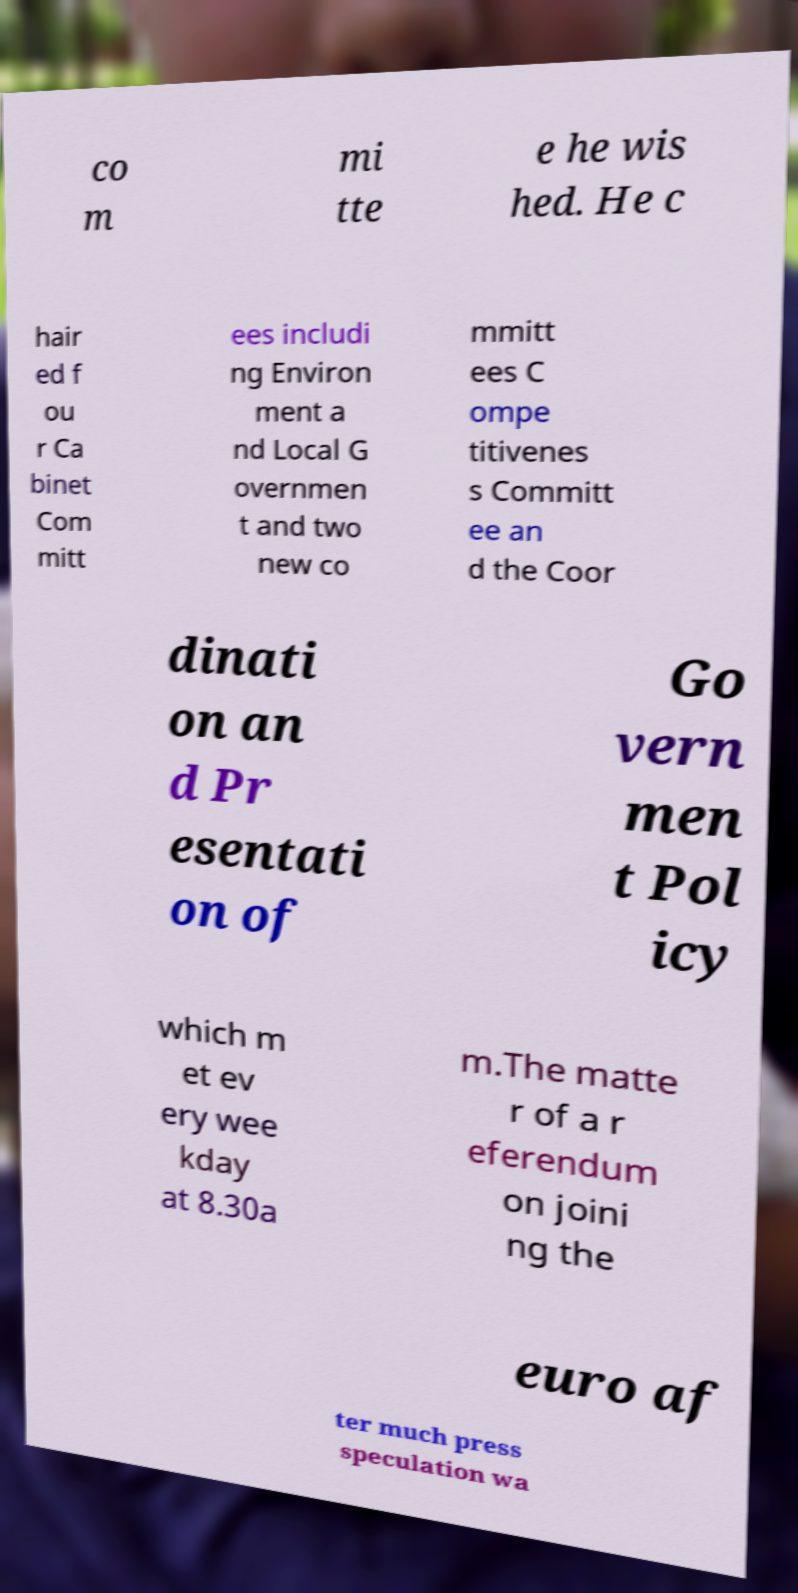What messages or text are displayed in this image? I need them in a readable, typed format. co m mi tte e he wis hed. He c hair ed f ou r Ca binet Com mitt ees includi ng Environ ment a nd Local G overnmen t and two new co mmitt ees C ompe titivenes s Committ ee an d the Coor dinati on an d Pr esentati on of Go vern men t Pol icy which m et ev ery wee kday at 8.30a m.The matte r of a r eferendum on joini ng the euro af ter much press speculation wa 